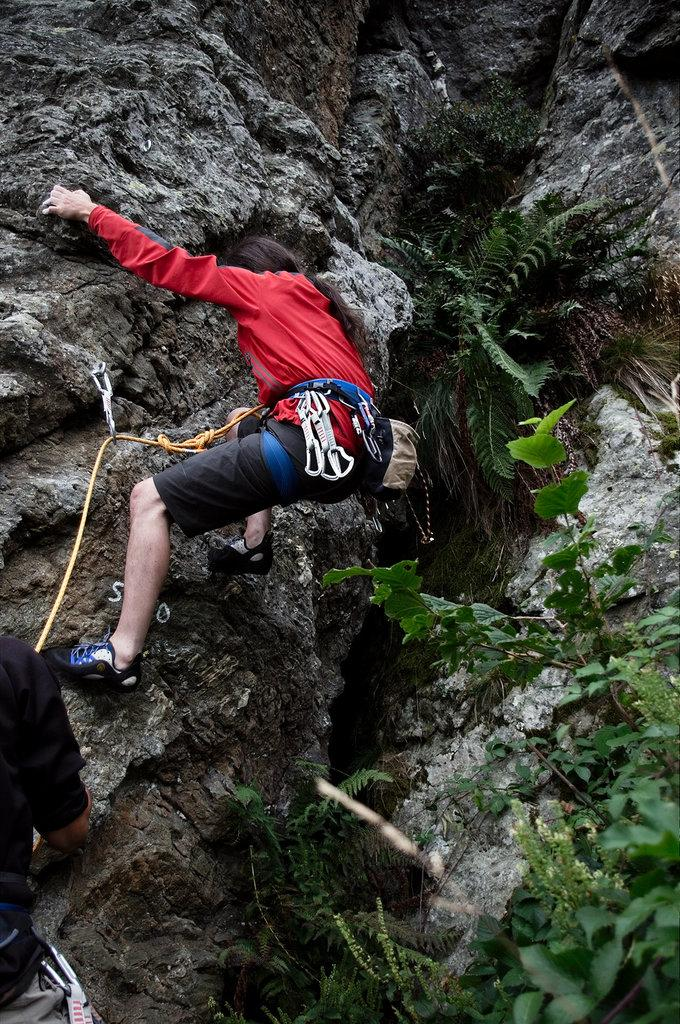Who is present in the image? There is a person in the image. What is the person doing in the image? The person is climbing a rock hill. What type of vegetation can be seen in the image? There are plants visible in the image. What equipment is being used by the person in the image? There is a rope in the image, which may be used for climbing or support. Can you describe any additional objects in the image? There is a clip in the image, which could be used to secure the rope or other items. What type of bomb can be seen in the image? There is no bomb present in the image. How is the paste being used by the person in the image? There is no paste present in the image. 